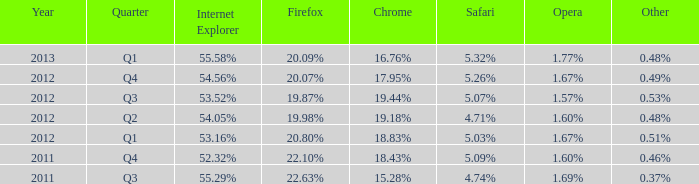Which safari took place during the 2012 q4 period? 5.26%. 